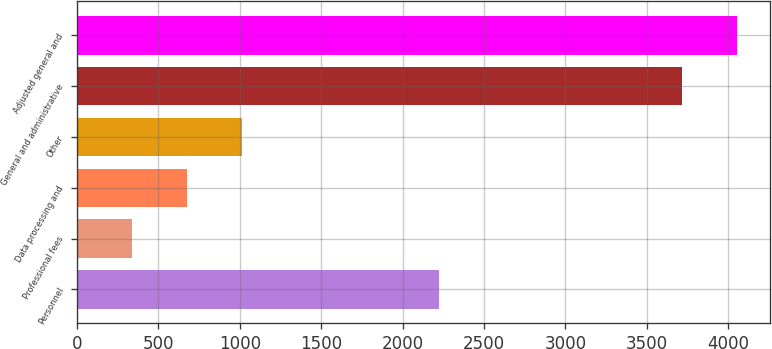Convert chart to OTSL. <chart><loc_0><loc_0><loc_500><loc_500><bar_chart><fcel>Personnel<fcel>Professional fees<fcel>Data processing and<fcel>Other<fcel>General and administrative<fcel>Adjusted general and<nl><fcel>2225<fcel>337<fcel>674.7<fcel>1012.4<fcel>3714<fcel>4051.7<nl></chart> 